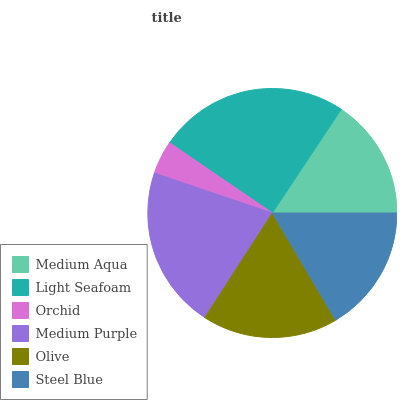Is Orchid the minimum?
Answer yes or no. Yes. Is Light Seafoam the maximum?
Answer yes or no. Yes. Is Light Seafoam the minimum?
Answer yes or no. No. Is Orchid the maximum?
Answer yes or no. No. Is Light Seafoam greater than Orchid?
Answer yes or no. Yes. Is Orchid less than Light Seafoam?
Answer yes or no. Yes. Is Orchid greater than Light Seafoam?
Answer yes or no. No. Is Light Seafoam less than Orchid?
Answer yes or no. No. Is Olive the high median?
Answer yes or no. Yes. Is Steel Blue the low median?
Answer yes or no. Yes. Is Medium Purple the high median?
Answer yes or no. No. Is Olive the low median?
Answer yes or no. No. 